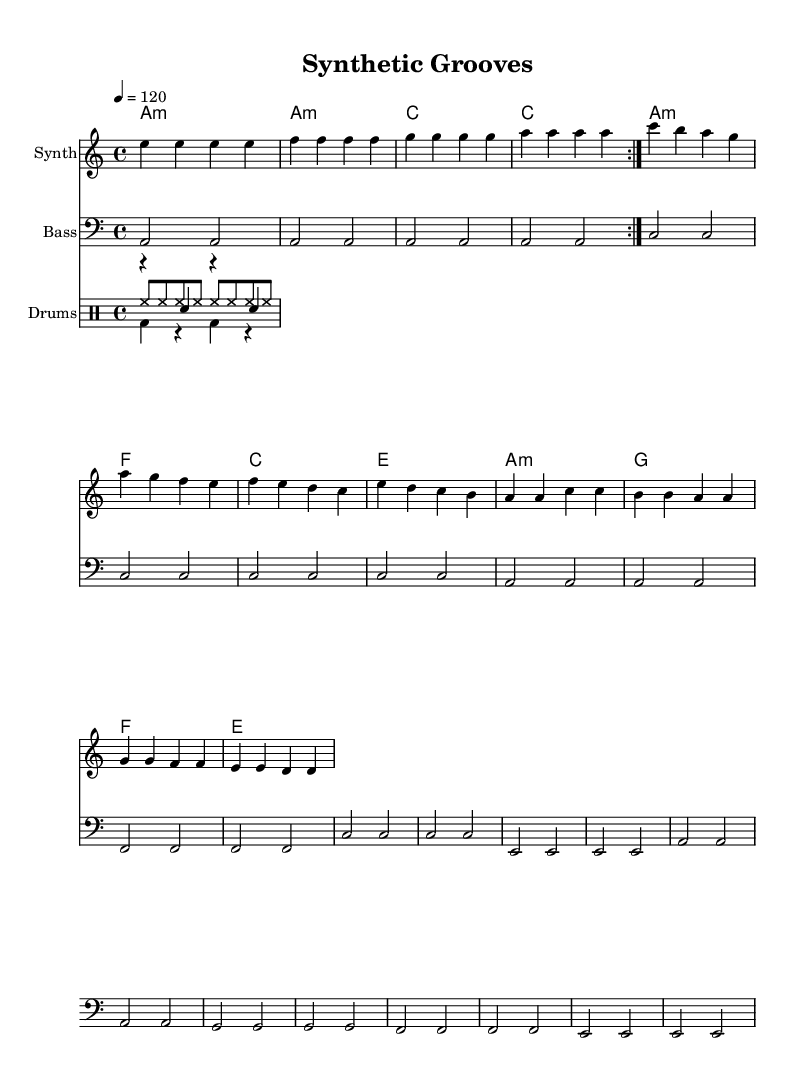What is the key signature of this music? The key signature is A minor, which has no sharps or flats, as indicated in the music.
Answer: A minor What is the time signature of this piece? The time signature is 4/4, which shows there are four beats per measure, common in disco music.
Answer: 4/4 What is the tempo marking shown in the score? The tempo marking is indicated as 120 beats per minute, which reflects the speed of the music.
Answer: 120 How many measures are in the synth melody section? The synth melody has a total of 16 measures, as counted through the provided music notation.
Answer: 16 What is the bass clef's primary note played throughout the piece? The primary note in the bass clef is A, dominant in the pattern as it is consistently repeated.
Answer: A What type of musical form is evident in the synth melody? The synth melody showcases a repeated section, indicated by the repeat volta symbol, typical in disco structures.
Answer: Repeated section What distinguishes the hi-hat pattern in this disco remix? The hi-hat pattern features consistent eighth notes, providing a steady rhythm characteristic of disco.
Answer: Eighth notes 